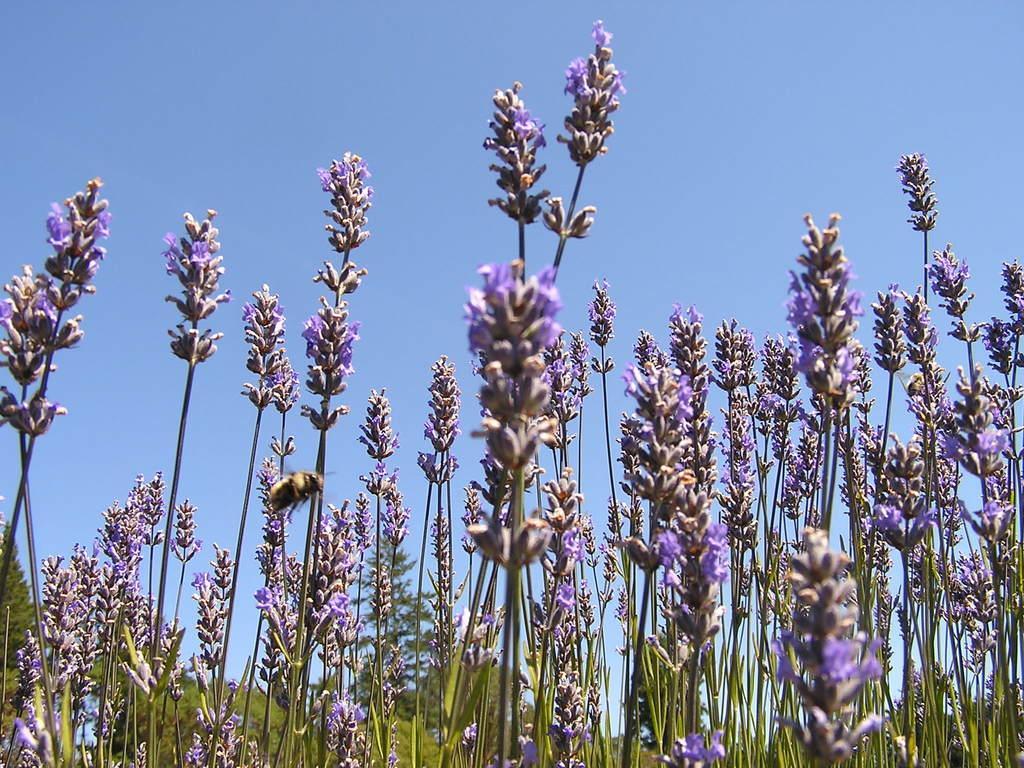Please provide a concise description of this image. In this image, we can see flowers, plants and stems. Here we can see an insect. Background we can see trees and sky. 